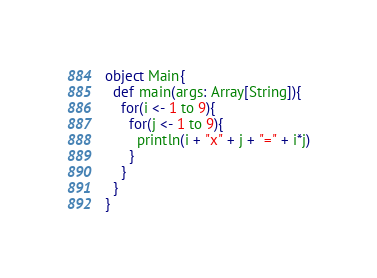Convert code to text. <code><loc_0><loc_0><loc_500><loc_500><_Scala_>object Main{
  def main(args: Array[String]){
    for(i <- 1 to 9){
      for(j <- 1 to 9){
        println(i + "x" + j + "=" + i*j)
      }
    }
  }
}</code> 